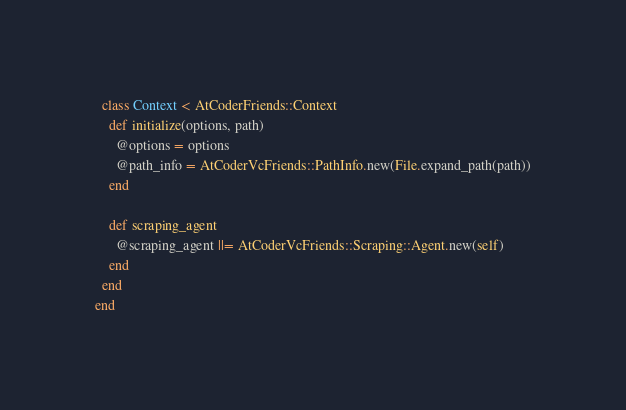Convert code to text. <code><loc_0><loc_0><loc_500><loc_500><_Ruby_>  class Context < AtCoderFriends::Context
    def initialize(options, path)
      @options = options
      @path_info = AtCoderVcFriends::PathInfo.new(File.expand_path(path))
    end

    def scraping_agent
      @scraping_agent ||= AtCoderVcFriends::Scraping::Agent.new(self)
    end
  end
end
</code> 